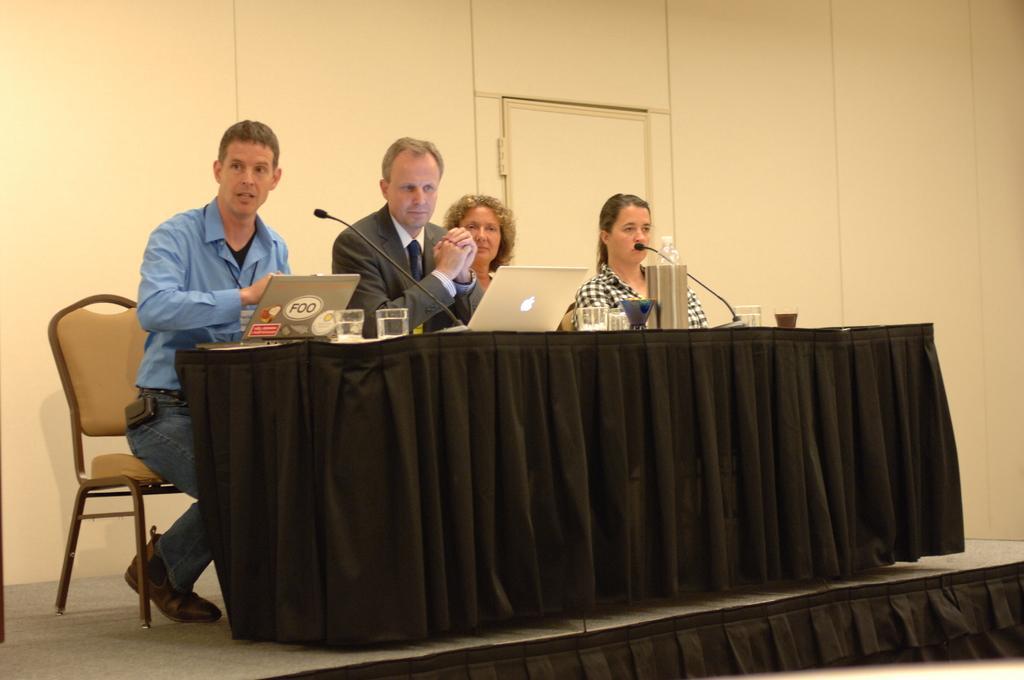Can you describe this image briefly? In this picture we can see two men and two women are sitting on chairs in front of a table, there are laptops, a water bottle, glasses present on the table, in the background there is a wall and a door. 